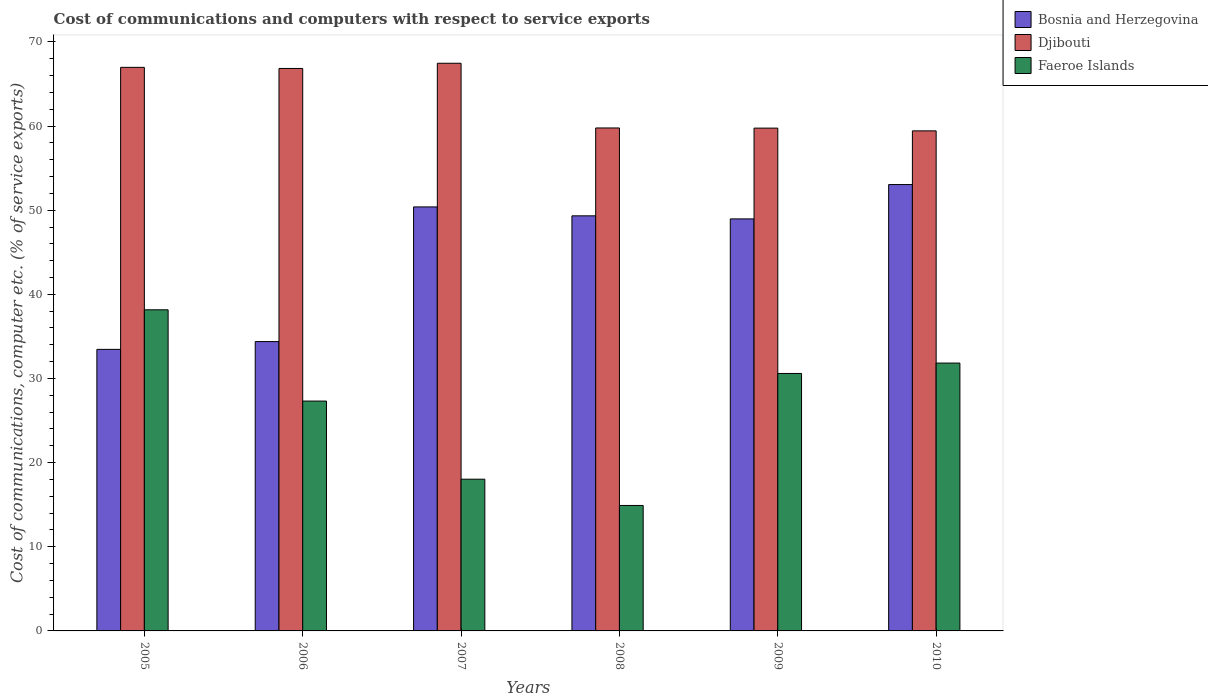How many different coloured bars are there?
Make the answer very short. 3. Are the number of bars on each tick of the X-axis equal?
Offer a very short reply. Yes. How many bars are there on the 4th tick from the right?
Your answer should be very brief. 3. In how many cases, is the number of bars for a given year not equal to the number of legend labels?
Ensure brevity in your answer.  0. What is the cost of communications and computers in Faeroe Islands in 2005?
Ensure brevity in your answer.  38.16. Across all years, what is the maximum cost of communications and computers in Faeroe Islands?
Make the answer very short. 38.16. Across all years, what is the minimum cost of communications and computers in Djibouti?
Provide a succinct answer. 59.43. In which year was the cost of communications and computers in Bosnia and Herzegovina minimum?
Offer a terse response. 2005. What is the total cost of communications and computers in Djibouti in the graph?
Offer a terse response. 380.24. What is the difference between the cost of communications and computers in Djibouti in 2005 and that in 2009?
Provide a succinct answer. 7.22. What is the difference between the cost of communications and computers in Faeroe Islands in 2005 and the cost of communications and computers in Djibouti in 2009?
Make the answer very short. -21.59. What is the average cost of communications and computers in Djibouti per year?
Provide a succinct answer. 63.37. In the year 2010, what is the difference between the cost of communications and computers in Bosnia and Herzegovina and cost of communications and computers in Faeroe Islands?
Your answer should be compact. 21.21. In how many years, is the cost of communications and computers in Djibouti greater than 32 %?
Your answer should be very brief. 6. What is the ratio of the cost of communications and computers in Faeroe Islands in 2006 to that in 2010?
Provide a succinct answer. 0.86. Is the cost of communications and computers in Bosnia and Herzegovina in 2009 less than that in 2010?
Provide a succinct answer. Yes. Is the difference between the cost of communications and computers in Bosnia and Herzegovina in 2005 and 2010 greater than the difference between the cost of communications and computers in Faeroe Islands in 2005 and 2010?
Keep it short and to the point. No. What is the difference between the highest and the second highest cost of communications and computers in Bosnia and Herzegovina?
Make the answer very short. 2.66. What is the difference between the highest and the lowest cost of communications and computers in Faeroe Islands?
Ensure brevity in your answer.  23.25. In how many years, is the cost of communications and computers in Djibouti greater than the average cost of communications and computers in Djibouti taken over all years?
Offer a terse response. 3. What does the 2nd bar from the left in 2009 represents?
Your answer should be compact. Djibouti. What does the 3rd bar from the right in 2009 represents?
Give a very brief answer. Bosnia and Herzegovina. What is the difference between two consecutive major ticks on the Y-axis?
Your answer should be compact. 10. Are the values on the major ticks of Y-axis written in scientific E-notation?
Offer a terse response. No. Does the graph contain any zero values?
Keep it short and to the point. No. Where does the legend appear in the graph?
Keep it short and to the point. Top right. How are the legend labels stacked?
Your answer should be compact. Vertical. What is the title of the graph?
Offer a very short reply. Cost of communications and computers with respect to service exports. What is the label or title of the X-axis?
Make the answer very short. Years. What is the label or title of the Y-axis?
Your answer should be very brief. Cost of communications, computer etc. (% of service exports). What is the Cost of communications, computer etc. (% of service exports) in Bosnia and Herzegovina in 2005?
Your answer should be very brief. 33.46. What is the Cost of communications, computer etc. (% of service exports) in Djibouti in 2005?
Make the answer very short. 66.98. What is the Cost of communications, computer etc. (% of service exports) in Faeroe Islands in 2005?
Offer a terse response. 38.16. What is the Cost of communications, computer etc. (% of service exports) of Bosnia and Herzegovina in 2006?
Keep it short and to the point. 34.38. What is the Cost of communications, computer etc. (% of service exports) of Djibouti in 2006?
Offer a very short reply. 66.84. What is the Cost of communications, computer etc. (% of service exports) in Faeroe Islands in 2006?
Make the answer very short. 27.32. What is the Cost of communications, computer etc. (% of service exports) of Bosnia and Herzegovina in 2007?
Your answer should be very brief. 50.39. What is the Cost of communications, computer etc. (% of service exports) in Djibouti in 2007?
Offer a terse response. 67.46. What is the Cost of communications, computer etc. (% of service exports) of Faeroe Islands in 2007?
Your answer should be compact. 18.03. What is the Cost of communications, computer etc. (% of service exports) in Bosnia and Herzegovina in 2008?
Your response must be concise. 49.33. What is the Cost of communications, computer etc. (% of service exports) in Djibouti in 2008?
Offer a very short reply. 59.77. What is the Cost of communications, computer etc. (% of service exports) of Faeroe Islands in 2008?
Ensure brevity in your answer.  14.91. What is the Cost of communications, computer etc. (% of service exports) of Bosnia and Herzegovina in 2009?
Offer a terse response. 48.97. What is the Cost of communications, computer etc. (% of service exports) of Djibouti in 2009?
Provide a short and direct response. 59.75. What is the Cost of communications, computer etc. (% of service exports) of Faeroe Islands in 2009?
Keep it short and to the point. 30.6. What is the Cost of communications, computer etc. (% of service exports) in Bosnia and Herzegovina in 2010?
Give a very brief answer. 53.05. What is the Cost of communications, computer etc. (% of service exports) in Djibouti in 2010?
Your response must be concise. 59.43. What is the Cost of communications, computer etc. (% of service exports) in Faeroe Islands in 2010?
Make the answer very short. 31.83. Across all years, what is the maximum Cost of communications, computer etc. (% of service exports) of Bosnia and Herzegovina?
Provide a short and direct response. 53.05. Across all years, what is the maximum Cost of communications, computer etc. (% of service exports) in Djibouti?
Your answer should be compact. 67.46. Across all years, what is the maximum Cost of communications, computer etc. (% of service exports) of Faeroe Islands?
Provide a succinct answer. 38.16. Across all years, what is the minimum Cost of communications, computer etc. (% of service exports) of Bosnia and Herzegovina?
Your response must be concise. 33.46. Across all years, what is the minimum Cost of communications, computer etc. (% of service exports) of Djibouti?
Ensure brevity in your answer.  59.43. Across all years, what is the minimum Cost of communications, computer etc. (% of service exports) in Faeroe Islands?
Your response must be concise. 14.91. What is the total Cost of communications, computer etc. (% of service exports) of Bosnia and Herzegovina in the graph?
Keep it short and to the point. 269.58. What is the total Cost of communications, computer etc. (% of service exports) in Djibouti in the graph?
Provide a short and direct response. 380.24. What is the total Cost of communications, computer etc. (% of service exports) in Faeroe Islands in the graph?
Your answer should be compact. 160.85. What is the difference between the Cost of communications, computer etc. (% of service exports) in Bosnia and Herzegovina in 2005 and that in 2006?
Give a very brief answer. -0.92. What is the difference between the Cost of communications, computer etc. (% of service exports) of Djibouti in 2005 and that in 2006?
Your response must be concise. 0.13. What is the difference between the Cost of communications, computer etc. (% of service exports) in Faeroe Islands in 2005 and that in 2006?
Your answer should be compact. 10.85. What is the difference between the Cost of communications, computer etc. (% of service exports) of Bosnia and Herzegovina in 2005 and that in 2007?
Provide a short and direct response. -16.93. What is the difference between the Cost of communications, computer etc. (% of service exports) of Djibouti in 2005 and that in 2007?
Make the answer very short. -0.49. What is the difference between the Cost of communications, computer etc. (% of service exports) of Faeroe Islands in 2005 and that in 2007?
Your answer should be very brief. 20.13. What is the difference between the Cost of communications, computer etc. (% of service exports) of Bosnia and Herzegovina in 2005 and that in 2008?
Offer a very short reply. -15.87. What is the difference between the Cost of communications, computer etc. (% of service exports) in Djibouti in 2005 and that in 2008?
Your response must be concise. 7.2. What is the difference between the Cost of communications, computer etc. (% of service exports) of Faeroe Islands in 2005 and that in 2008?
Your answer should be compact. 23.25. What is the difference between the Cost of communications, computer etc. (% of service exports) in Bosnia and Herzegovina in 2005 and that in 2009?
Ensure brevity in your answer.  -15.51. What is the difference between the Cost of communications, computer etc. (% of service exports) in Djibouti in 2005 and that in 2009?
Keep it short and to the point. 7.22. What is the difference between the Cost of communications, computer etc. (% of service exports) of Faeroe Islands in 2005 and that in 2009?
Provide a succinct answer. 7.56. What is the difference between the Cost of communications, computer etc. (% of service exports) in Bosnia and Herzegovina in 2005 and that in 2010?
Give a very brief answer. -19.59. What is the difference between the Cost of communications, computer etc. (% of service exports) of Djibouti in 2005 and that in 2010?
Offer a terse response. 7.55. What is the difference between the Cost of communications, computer etc. (% of service exports) of Faeroe Islands in 2005 and that in 2010?
Provide a short and direct response. 6.33. What is the difference between the Cost of communications, computer etc. (% of service exports) in Bosnia and Herzegovina in 2006 and that in 2007?
Offer a terse response. -16.01. What is the difference between the Cost of communications, computer etc. (% of service exports) of Djibouti in 2006 and that in 2007?
Ensure brevity in your answer.  -0.62. What is the difference between the Cost of communications, computer etc. (% of service exports) in Faeroe Islands in 2006 and that in 2007?
Give a very brief answer. 9.28. What is the difference between the Cost of communications, computer etc. (% of service exports) in Bosnia and Herzegovina in 2006 and that in 2008?
Your answer should be very brief. -14.95. What is the difference between the Cost of communications, computer etc. (% of service exports) of Djibouti in 2006 and that in 2008?
Ensure brevity in your answer.  7.07. What is the difference between the Cost of communications, computer etc. (% of service exports) of Faeroe Islands in 2006 and that in 2008?
Your answer should be very brief. 12.41. What is the difference between the Cost of communications, computer etc. (% of service exports) in Bosnia and Herzegovina in 2006 and that in 2009?
Provide a short and direct response. -14.58. What is the difference between the Cost of communications, computer etc. (% of service exports) in Djibouti in 2006 and that in 2009?
Make the answer very short. 7.09. What is the difference between the Cost of communications, computer etc. (% of service exports) in Faeroe Islands in 2006 and that in 2009?
Give a very brief answer. -3.28. What is the difference between the Cost of communications, computer etc. (% of service exports) of Bosnia and Herzegovina in 2006 and that in 2010?
Offer a very short reply. -18.66. What is the difference between the Cost of communications, computer etc. (% of service exports) in Djibouti in 2006 and that in 2010?
Keep it short and to the point. 7.42. What is the difference between the Cost of communications, computer etc. (% of service exports) of Faeroe Islands in 2006 and that in 2010?
Offer a terse response. -4.52. What is the difference between the Cost of communications, computer etc. (% of service exports) of Bosnia and Herzegovina in 2007 and that in 2008?
Offer a very short reply. 1.06. What is the difference between the Cost of communications, computer etc. (% of service exports) of Djibouti in 2007 and that in 2008?
Offer a very short reply. 7.69. What is the difference between the Cost of communications, computer etc. (% of service exports) of Faeroe Islands in 2007 and that in 2008?
Your response must be concise. 3.12. What is the difference between the Cost of communications, computer etc. (% of service exports) of Bosnia and Herzegovina in 2007 and that in 2009?
Offer a terse response. 1.42. What is the difference between the Cost of communications, computer etc. (% of service exports) of Djibouti in 2007 and that in 2009?
Ensure brevity in your answer.  7.71. What is the difference between the Cost of communications, computer etc. (% of service exports) in Faeroe Islands in 2007 and that in 2009?
Your response must be concise. -12.57. What is the difference between the Cost of communications, computer etc. (% of service exports) in Bosnia and Herzegovina in 2007 and that in 2010?
Offer a very short reply. -2.66. What is the difference between the Cost of communications, computer etc. (% of service exports) of Djibouti in 2007 and that in 2010?
Keep it short and to the point. 8.04. What is the difference between the Cost of communications, computer etc. (% of service exports) in Faeroe Islands in 2007 and that in 2010?
Ensure brevity in your answer.  -13.8. What is the difference between the Cost of communications, computer etc. (% of service exports) of Bosnia and Herzegovina in 2008 and that in 2009?
Keep it short and to the point. 0.36. What is the difference between the Cost of communications, computer etc. (% of service exports) of Djibouti in 2008 and that in 2009?
Give a very brief answer. 0.02. What is the difference between the Cost of communications, computer etc. (% of service exports) in Faeroe Islands in 2008 and that in 2009?
Provide a short and direct response. -15.69. What is the difference between the Cost of communications, computer etc. (% of service exports) in Bosnia and Herzegovina in 2008 and that in 2010?
Your answer should be compact. -3.72. What is the difference between the Cost of communications, computer etc. (% of service exports) of Djibouti in 2008 and that in 2010?
Provide a short and direct response. 0.35. What is the difference between the Cost of communications, computer etc. (% of service exports) in Faeroe Islands in 2008 and that in 2010?
Offer a terse response. -16.92. What is the difference between the Cost of communications, computer etc. (% of service exports) in Bosnia and Herzegovina in 2009 and that in 2010?
Provide a succinct answer. -4.08. What is the difference between the Cost of communications, computer etc. (% of service exports) of Djibouti in 2009 and that in 2010?
Provide a short and direct response. 0.33. What is the difference between the Cost of communications, computer etc. (% of service exports) of Faeroe Islands in 2009 and that in 2010?
Your answer should be compact. -1.24. What is the difference between the Cost of communications, computer etc. (% of service exports) in Bosnia and Herzegovina in 2005 and the Cost of communications, computer etc. (% of service exports) in Djibouti in 2006?
Your answer should be compact. -33.38. What is the difference between the Cost of communications, computer etc. (% of service exports) of Bosnia and Herzegovina in 2005 and the Cost of communications, computer etc. (% of service exports) of Faeroe Islands in 2006?
Make the answer very short. 6.14. What is the difference between the Cost of communications, computer etc. (% of service exports) of Djibouti in 2005 and the Cost of communications, computer etc. (% of service exports) of Faeroe Islands in 2006?
Provide a succinct answer. 39.66. What is the difference between the Cost of communications, computer etc. (% of service exports) in Bosnia and Herzegovina in 2005 and the Cost of communications, computer etc. (% of service exports) in Djibouti in 2007?
Keep it short and to the point. -34. What is the difference between the Cost of communications, computer etc. (% of service exports) in Bosnia and Herzegovina in 2005 and the Cost of communications, computer etc. (% of service exports) in Faeroe Islands in 2007?
Offer a very short reply. 15.43. What is the difference between the Cost of communications, computer etc. (% of service exports) of Djibouti in 2005 and the Cost of communications, computer etc. (% of service exports) of Faeroe Islands in 2007?
Provide a short and direct response. 48.94. What is the difference between the Cost of communications, computer etc. (% of service exports) in Bosnia and Herzegovina in 2005 and the Cost of communications, computer etc. (% of service exports) in Djibouti in 2008?
Give a very brief answer. -26.31. What is the difference between the Cost of communications, computer etc. (% of service exports) in Bosnia and Herzegovina in 2005 and the Cost of communications, computer etc. (% of service exports) in Faeroe Islands in 2008?
Your response must be concise. 18.55. What is the difference between the Cost of communications, computer etc. (% of service exports) in Djibouti in 2005 and the Cost of communications, computer etc. (% of service exports) in Faeroe Islands in 2008?
Offer a terse response. 52.07. What is the difference between the Cost of communications, computer etc. (% of service exports) of Bosnia and Herzegovina in 2005 and the Cost of communications, computer etc. (% of service exports) of Djibouti in 2009?
Provide a succinct answer. -26.3. What is the difference between the Cost of communications, computer etc. (% of service exports) of Bosnia and Herzegovina in 2005 and the Cost of communications, computer etc. (% of service exports) of Faeroe Islands in 2009?
Ensure brevity in your answer.  2.86. What is the difference between the Cost of communications, computer etc. (% of service exports) in Djibouti in 2005 and the Cost of communications, computer etc. (% of service exports) in Faeroe Islands in 2009?
Provide a succinct answer. 36.38. What is the difference between the Cost of communications, computer etc. (% of service exports) of Bosnia and Herzegovina in 2005 and the Cost of communications, computer etc. (% of service exports) of Djibouti in 2010?
Offer a terse response. -25.97. What is the difference between the Cost of communications, computer etc. (% of service exports) in Bosnia and Herzegovina in 2005 and the Cost of communications, computer etc. (% of service exports) in Faeroe Islands in 2010?
Your response must be concise. 1.63. What is the difference between the Cost of communications, computer etc. (% of service exports) in Djibouti in 2005 and the Cost of communications, computer etc. (% of service exports) in Faeroe Islands in 2010?
Your answer should be compact. 35.14. What is the difference between the Cost of communications, computer etc. (% of service exports) in Bosnia and Herzegovina in 2006 and the Cost of communications, computer etc. (% of service exports) in Djibouti in 2007?
Make the answer very short. -33.08. What is the difference between the Cost of communications, computer etc. (% of service exports) of Bosnia and Herzegovina in 2006 and the Cost of communications, computer etc. (% of service exports) of Faeroe Islands in 2007?
Offer a terse response. 16.35. What is the difference between the Cost of communications, computer etc. (% of service exports) of Djibouti in 2006 and the Cost of communications, computer etc. (% of service exports) of Faeroe Islands in 2007?
Your answer should be compact. 48.81. What is the difference between the Cost of communications, computer etc. (% of service exports) in Bosnia and Herzegovina in 2006 and the Cost of communications, computer etc. (% of service exports) in Djibouti in 2008?
Your answer should be compact. -25.39. What is the difference between the Cost of communications, computer etc. (% of service exports) of Bosnia and Herzegovina in 2006 and the Cost of communications, computer etc. (% of service exports) of Faeroe Islands in 2008?
Your response must be concise. 19.47. What is the difference between the Cost of communications, computer etc. (% of service exports) of Djibouti in 2006 and the Cost of communications, computer etc. (% of service exports) of Faeroe Islands in 2008?
Provide a short and direct response. 51.93. What is the difference between the Cost of communications, computer etc. (% of service exports) in Bosnia and Herzegovina in 2006 and the Cost of communications, computer etc. (% of service exports) in Djibouti in 2009?
Make the answer very short. -25.37. What is the difference between the Cost of communications, computer etc. (% of service exports) of Bosnia and Herzegovina in 2006 and the Cost of communications, computer etc. (% of service exports) of Faeroe Islands in 2009?
Ensure brevity in your answer.  3.79. What is the difference between the Cost of communications, computer etc. (% of service exports) of Djibouti in 2006 and the Cost of communications, computer etc. (% of service exports) of Faeroe Islands in 2009?
Ensure brevity in your answer.  36.25. What is the difference between the Cost of communications, computer etc. (% of service exports) in Bosnia and Herzegovina in 2006 and the Cost of communications, computer etc. (% of service exports) in Djibouti in 2010?
Provide a short and direct response. -25.04. What is the difference between the Cost of communications, computer etc. (% of service exports) in Bosnia and Herzegovina in 2006 and the Cost of communications, computer etc. (% of service exports) in Faeroe Islands in 2010?
Offer a terse response. 2.55. What is the difference between the Cost of communications, computer etc. (% of service exports) of Djibouti in 2006 and the Cost of communications, computer etc. (% of service exports) of Faeroe Islands in 2010?
Your answer should be very brief. 35.01. What is the difference between the Cost of communications, computer etc. (% of service exports) in Bosnia and Herzegovina in 2007 and the Cost of communications, computer etc. (% of service exports) in Djibouti in 2008?
Your answer should be compact. -9.38. What is the difference between the Cost of communications, computer etc. (% of service exports) of Bosnia and Herzegovina in 2007 and the Cost of communications, computer etc. (% of service exports) of Faeroe Islands in 2008?
Provide a short and direct response. 35.48. What is the difference between the Cost of communications, computer etc. (% of service exports) of Djibouti in 2007 and the Cost of communications, computer etc. (% of service exports) of Faeroe Islands in 2008?
Provide a succinct answer. 52.55. What is the difference between the Cost of communications, computer etc. (% of service exports) of Bosnia and Herzegovina in 2007 and the Cost of communications, computer etc. (% of service exports) of Djibouti in 2009?
Offer a terse response. -9.36. What is the difference between the Cost of communications, computer etc. (% of service exports) in Bosnia and Herzegovina in 2007 and the Cost of communications, computer etc. (% of service exports) in Faeroe Islands in 2009?
Offer a terse response. 19.79. What is the difference between the Cost of communications, computer etc. (% of service exports) of Djibouti in 2007 and the Cost of communications, computer etc. (% of service exports) of Faeroe Islands in 2009?
Ensure brevity in your answer.  36.87. What is the difference between the Cost of communications, computer etc. (% of service exports) of Bosnia and Herzegovina in 2007 and the Cost of communications, computer etc. (% of service exports) of Djibouti in 2010?
Your response must be concise. -9.04. What is the difference between the Cost of communications, computer etc. (% of service exports) in Bosnia and Herzegovina in 2007 and the Cost of communications, computer etc. (% of service exports) in Faeroe Islands in 2010?
Provide a succinct answer. 18.56. What is the difference between the Cost of communications, computer etc. (% of service exports) in Djibouti in 2007 and the Cost of communications, computer etc. (% of service exports) in Faeroe Islands in 2010?
Give a very brief answer. 35.63. What is the difference between the Cost of communications, computer etc. (% of service exports) in Bosnia and Herzegovina in 2008 and the Cost of communications, computer etc. (% of service exports) in Djibouti in 2009?
Provide a succinct answer. -10.42. What is the difference between the Cost of communications, computer etc. (% of service exports) in Bosnia and Herzegovina in 2008 and the Cost of communications, computer etc. (% of service exports) in Faeroe Islands in 2009?
Offer a terse response. 18.73. What is the difference between the Cost of communications, computer etc. (% of service exports) in Djibouti in 2008 and the Cost of communications, computer etc. (% of service exports) in Faeroe Islands in 2009?
Your answer should be very brief. 29.18. What is the difference between the Cost of communications, computer etc. (% of service exports) in Bosnia and Herzegovina in 2008 and the Cost of communications, computer etc. (% of service exports) in Djibouti in 2010?
Your answer should be compact. -10.1. What is the difference between the Cost of communications, computer etc. (% of service exports) of Bosnia and Herzegovina in 2008 and the Cost of communications, computer etc. (% of service exports) of Faeroe Islands in 2010?
Ensure brevity in your answer.  17.5. What is the difference between the Cost of communications, computer etc. (% of service exports) in Djibouti in 2008 and the Cost of communications, computer etc. (% of service exports) in Faeroe Islands in 2010?
Your response must be concise. 27.94. What is the difference between the Cost of communications, computer etc. (% of service exports) of Bosnia and Herzegovina in 2009 and the Cost of communications, computer etc. (% of service exports) of Djibouti in 2010?
Your answer should be very brief. -10.46. What is the difference between the Cost of communications, computer etc. (% of service exports) in Bosnia and Herzegovina in 2009 and the Cost of communications, computer etc. (% of service exports) in Faeroe Islands in 2010?
Make the answer very short. 17.13. What is the difference between the Cost of communications, computer etc. (% of service exports) of Djibouti in 2009 and the Cost of communications, computer etc. (% of service exports) of Faeroe Islands in 2010?
Offer a very short reply. 27.92. What is the average Cost of communications, computer etc. (% of service exports) of Bosnia and Herzegovina per year?
Make the answer very short. 44.93. What is the average Cost of communications, computer etc. (% of service exports) of Djibouti per year?
Your answer should be very brief. 63.37. What is the average Cost of communications, computer etc. (% of service exports) in Faeroe Islands per year?
Offer a very short reply. 26.81. In the year 2005, what is the difference between the Cost of communications, computer etc. (% of service exports) in Bosnia and Herzegovina and Cost of communications, computer etc. (% of service exports) in Djibouti?
Ensure brevity in your answer.  -33.52. In the year 2005, what is the difference between the Cost of communications, computer etc. (% of service exports) of Bosnia and Herzegovina and Cost of communications, computer etc. (% of service exports) of Faeroe Islands?
Provide a succinct answer. -4.7. In the year 2005, what is the difference between the Cost of communications, computer etc. (% of service exports) of Djibouti and Cost of communications, computer etc. (% of service exports) of Faeroe Islands?
Your response must be concise. 28.81. In the year 2006, what is the difference between the Cost of communications, computer etc. (% of service exports) of Bosnia and Herzegovina and Cost of communications, computer etc. (% of service exports) of Djibouti?
Make the answer very short. -32.46. In the year 2006, what is the difference between the Cost of communications, computer etc. (% of service exports) of Bosnia and Herzegovina and Cost of communications, computer etc. (% of service exports) of Faeroe Islands?
Give a very brief answer. 7.07. In the year 2006, what is the difference between the Cost of communications, computer etc. (% of service exports) in Djibouti and Cost of communications, computer etc. (% of service exports) in Faeroe Islands?
Offer a terse response. 39.53. In the year 2007, what is the difference between the Cost of communications, computer etc. (% of service exports) of Bosnia and Herzegovina and Cost of communications, computer etc. (% of service exports) of Djibouti?
Your answer should be very brief. -17.07. In the year 2007, what is the difference between the Cost of communications, computer etc. (% of service exports) in Bosnia and Herzegovina and Cost of communications, computer etc. (% of service exports) in Faeroe Islands?
Your answer should be compact. 32.36. In the year 2007, what is the difference between the Cost of communications, computer etc. (% of service exports) of Djibouti and Cost of communications, computer etc. (% of service exports) of Faeroe Islands?
Offer a very short reply. 49.43. In the year 2008, what is the difference between the Cost of communications, computer etc. (% of service exports) of Bosnia and Herzegovina and Cost of communications, computer etc. (% of service exports) of Djibouti?
Provide a short and direct response. -10.44. In the year 2008, what is the difference between the Cost of communications, computer etc. (% of service exports) in Bosnia and Herzegovina and Cost of communications, computer etc. (% of service exports) in Faeroe Islands?
Provide a short and direct response. 34.42. In the year 2008, what is the difference between the Cost of communications, computer etc. (% of service exports) in Djibouti and Cost of communications, computer etc. (% of service exports) in Faeroe Islands?
Offer a terse response. 44.86. In the year 2009, what is the difference between the Cost of communications, computer etc. (% of service exports) in Bosnia and Herzegovina and Cost of communications, computer etc. (% of service exports) in Djibouti?
Provide a short and direct response. -10.79. In the year 2009, what is the difference between the Cost of communications, computer etc. (% of service exports) in Bosnia and Herzegovina and Cost of communications, computer etc. (% of service exports) in Faeroe Islands?
Your response must be concise. 18.37. In the year 2009, what is the difference between the Cost of communications, computer etc. (% of service exports) of Djibouti and Cost of communications, computer etc. (% of service exports) of Faeroe Islands?
Provide a short and direct response. 29.16. In the year 2010, what is the difference between the Cost of communications, computer etc. (% of service exports) of Bosnia and Herzegovina and Cost of communications, computer etc. (% of service exports) of Djibouti?
Provide a short and direct response. -6.38. In the year 2010, what is the difference between the Cost of communications, computer etc. (% of service exports) in Bosnia and Herzegovina and Cost of communications, computer etc. (% of service exports) in Faeroe Islands?
Provide a short and direct response. 21.21. In the year 2010, what is the difference between the Cost of communications, computer etc. (% of service exports) of Djibouti and Cost of communications, computer etc. (% of service exports) of Faeroe Islands?
Offer a very short reply. 27.59. What is the ratio of the Cost of communications, computer etc. (% of service exports) of Bosnia and Herzegovina in 2005 to that in 2006?
Make the answer very short. 0.97. What is the ratio of the Cost of communications, computer etc. (% of service exports) in Djibouti in 2005 to that in 2006?
Your response must be concise. 1. What is the ratio of the Cost of communications, computer etc. (% of service exports) in Faeroe Islands in 2005 to that in 2006?
Ensure brevity in your answer.  1.4. What is the ratio of the Cost of communications, computer etc. (% of service exports) of Bosnia and Herzegovina in 2005 to that in 2007?
Give a very brief answer. 0.66. What is the ratio of the Cost of communications, computer etc. (% of service exports) of Djibouti in 2005 to that in 2007?
Offer a terse response. 0.99. What is the ratio of the Cost of communications, computer etc. (% of service exports) of Faeroe Islands in 2005 to that in 2007?
Your response must be concise. 2.12. What is the ratio of the Cost of communications, computer etc. (% of service exports) of Bosnia and Herzegovina in 2005 to that in 2008?
Provide a short and direct response. 0.68. What is the ratio of the Cost of communications, computer etc. (% of service exports) in Djibouti in 2005 to that in 2008?
Offer a very short reply. 1.12. What is the ratio of the Cost of communications, computer etc. (% of service exports) of Faeroe Islands in 2005 to that in 2008?
Your answer should be compact. 2.56. What is the ratio of the Cost of communications, computer etc. (% of service exports) of Bosnia and Herzegovina in 2005 to that in 2009?
Offer a very short reply. 0.68. What is the ratio of the Cost of communications, computer etc. (% of service exports) in Djibouti in 2005 to that in 2009?
Offer a very short reply. 1.12. What is the ratio of the Cost of communications, computer etc. (% of service exports) in Faeroe Islands in 2005 to that in 2009?
Your response must be concise. 1.25. What is the ratio of the Cost of communications, computer etc. (% of service exports) in Bosnia and Herzegovina in 2005 to that in 2010?
Ensure brevity in your answer.  0.63. What is the ratio of the Cost of communications, computer etc. (% of service exports) in Djibouti in 2005 to that in 2010?
Offer a very short reply. 1.13. What is the ratio of the Cost of communications, computer etc. (% of service exports) of Faeroe Islands in 2005 to that in 2010?
Your answer should be compact. 1.2. What is the ratio of the Cost of communications, computer etc. (% of service exports) of Bosnia and Herzegovina in 2006 to that in 2007?
Your response must be concise. 0.68. What is the ratio of the Cost of communications, computer etc. (% of service exports) of Faeroe Islands in 2006 to that in 2007?
Give a very brief answer. 1.51. What is the ratio of the Cost of communications, computer etc. (% of service exports) in Bosnia and Herzegovina in 2006 to that in 2008?
Offer a very short reply. 0.7. What is the ratio of the Cost of communications, computer etc. (% of service exports) in Djibouti in 2006 to that in 2008?
Make the answer very short. 1.12. What is the ratio of the Cost of communications, computer etc. (% of service exports) of Faeroe Islands in 2006 to that in 2008?
Offer a terse response. 1.83. What is the ratio of the Cost of communications, computer etc. (% of service exports) in Bosnia and Herzegovina in 2006 to that in 2009?
Give a very brief answer. 0.7. What is the ratio of the Cost of communications, computer etc. (% of service exports) in Djibouti in 2006 to that in 2009?
Your answer should be compact. 1.12. What is the ratio of the Cost of communications, computer etc. (% of service exports) of Faeroe Islands in 2006 to that in 2009?
Give a very brief answer. 0.89. What is the ratio of the Cost of communications, computer etc. (% of service exports) in Bosnia and Herzegovina in 2006 to that in 2010?
Offer a terse response. 0.65. What is the ratio of the Cost of communications, computer etc. (% of service exports) in Djibouti in 2006 to that in 2010?
Keep it short and to the point. 1.12. What is the ratio of the Cost of communications, computer etc. (% of service exports) in Faeroe Islands in 2006 to that in 2010?
Your answer should be very brief. 0.86. What is the ratio of the Cost of communications, computer etc. (% of service exports) in Bosnia and Herzegovina in 2007 to that in 2008?
Offer a very short reply. 1.02. What is the ratio of the Cost of communications, computer etc. (% of service exports) of Djibouti in 2007 to that in 2008?
Make the answer very short. 1.13. What is the ratio of the Cost of communications, computer etc. (% of service exports) in Faeroe Islands in 2007 to that in 2008?
Keep it short and to the point. 1.21. What is the ratio of the Cost of communications, computer etc. (% of service exports) in Bosnia and Herzegovina in 2007 to that in 2009?
Give a very brief answer. 1.03. What is the ratio of the Cost of communications, computer etc. (% of service exports) of Djibouti in 2007 to that in 2009?
Your answer should be very brief. 1.13. What is the ratio of the Cost of communications, computer etc. (% of service exports) in Faeroe Islands in 2007 to that in 2009?
Make the answer very short. 0.59. What is the ratio of the Cost of communications, computer etc. (% of service exports) of Bosnia and Herzegovina in 2007 to that in 2010?
Provide a short and direct response. 0.95. What is the ratio of the Cost of communications, computer etc. (% of service exports) of Djibouti in 2007 to that in 2010?
Provide a succinct answer. 1.14. What is the ratio of the Cost of communications, computer etc. (% of service exports) of Faeroe Islands in 2007 to that in 2010?
Your response must be concise. 0.57. What is the ratio of the Cost of communications, computer etc. (% of service exports) in Bosnia and Herzegovina in 2008 to that in 2009?
Make the answer very short. 1.01. What is the ratio of the Cost of communications, computer etc. (% of service exports) of Faeroe Islands in 2008 to that in 2009?
Your response must be concise. 0.49. What is the ratio of the Cost of communications, computer etc. (% of service exports) in Bosnia and Herzegovina in 2008 to that in 2010?
Ensure brevity in your answer.  0.93. What is the ratio of the Cost of communications, computer etc. (% of service exports) in Faeroe Islands in 2008 to that in 2010?
Your answer should be compact. 0.47. What is the ratio of the Cost of communications, computer etc. (% of service exports) in Bosnia and Herzegovina in 2009 to that in 2010?
Keep it short and to the point. 0.92. What is the ratio of the Cost of communications, computer etc. (% of service exports) of Faeroe Islands in 2009 to that in 2010?
Your answer should be very brief. 0.96. What is the difference between the highest and the second highest Cost of communications, computer etc. (% of service exports) in Bosnia and Herzegovina?
Your response must be concise. 2.66. What is the difference between the highest and the second highest Cost of communications, computer etc. (% of service exports) of Djibouti?
Provide a succinct answer. 0.49. What is the difference between the highest and the second highest Cost of communications, computer etc. (% of service exports) in Faeroe Islands?
Keep it short and to the point. 6.33. What is the difference between the highest and the lowest Cost of communications, computer etc. (% of service exports) of Bosnia and Herzegovina?
Provide a succinct answer. 19.59. What is the difference between the highest and the lowest Cost of communications, computer etc. (% of service exports) in Djibouti?
Give a very brief answer. 8.04. What is the difference between the highest and the lowest Cost of communications, computer etc. (% of service exports) of Faeroe Islands?
Your answer should be compact. 23.25. 